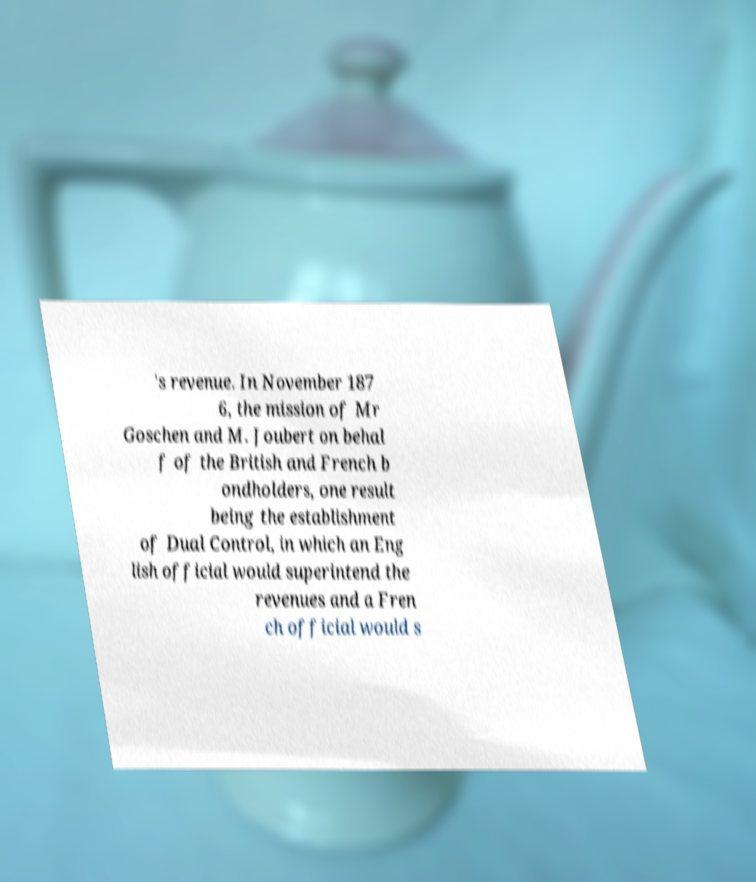What messages or text are displayed in this image? I need them in a readable, typed format. 's revenue. In November 187 6, the mission of Mr Goschen and M. Joubert on behal f of the British and French b ondholders, one result being the establishment of Dual Control, in which an Eng lish official would superintend the revenues and a Fren ch official would s 